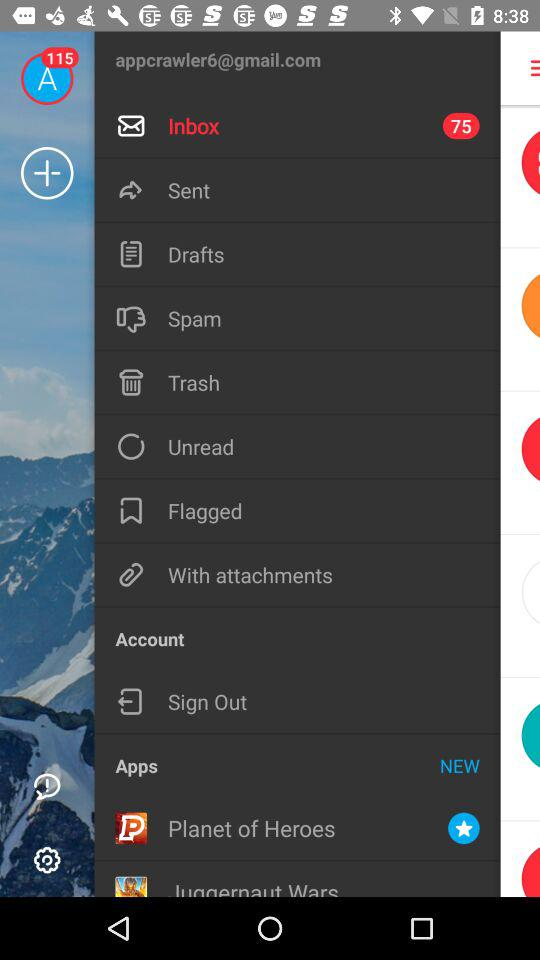How many unread emails are in the inbox? There are 75 unread emails. 